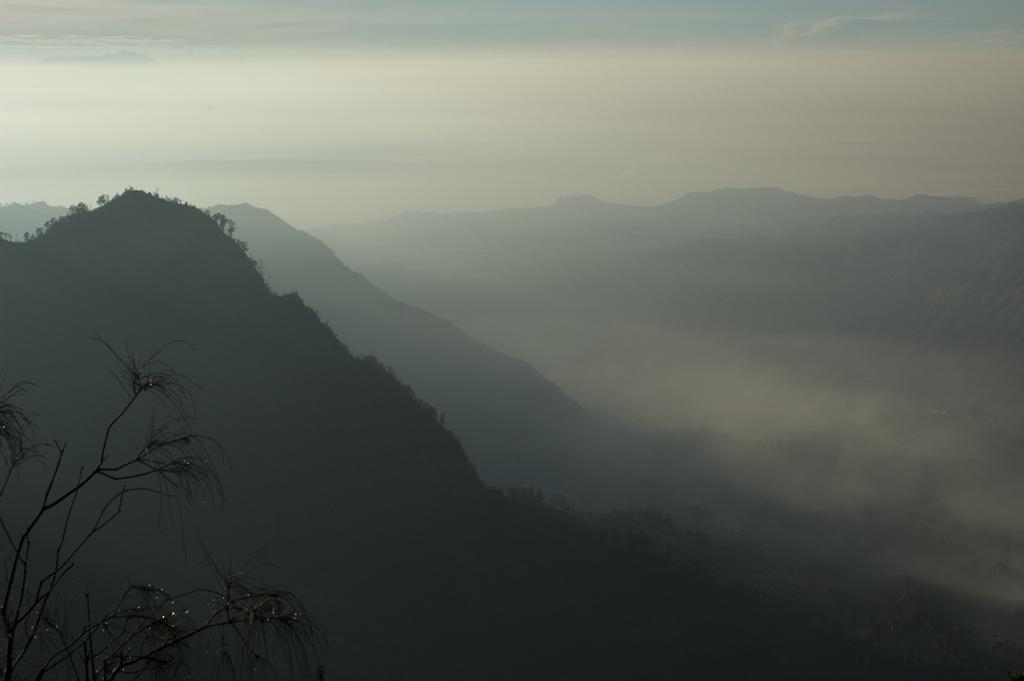Please provide a concise description of this image. This picture is clicked in the outskirts. At the bottom of the picture, we see a tree. There are trees and hills in the background. These trees and hills are covered with the fog. At the top of the picture, we see the sky. 